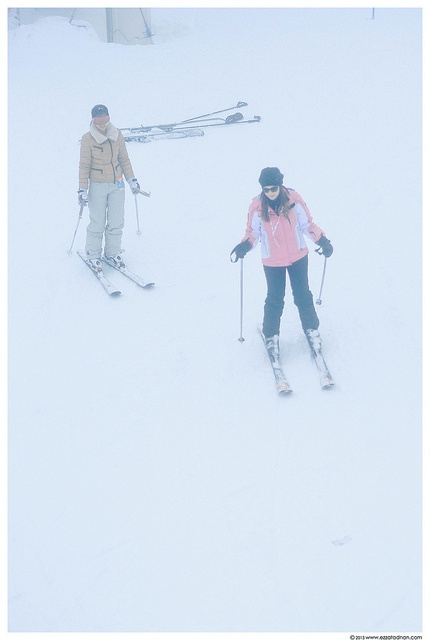Describe the objects in this image and their specific colors. I can see people in white, gray, pink, lavender, and darkgray tones, people in white, darkgray, lightblue, and lightgray tones, skis in white, lavender, darkgray, and lightblue tones, skis in white, lavender, darkgray, and lightblue tones, and skis in white, lavender, darkgray, and lightblue tones in this image. 